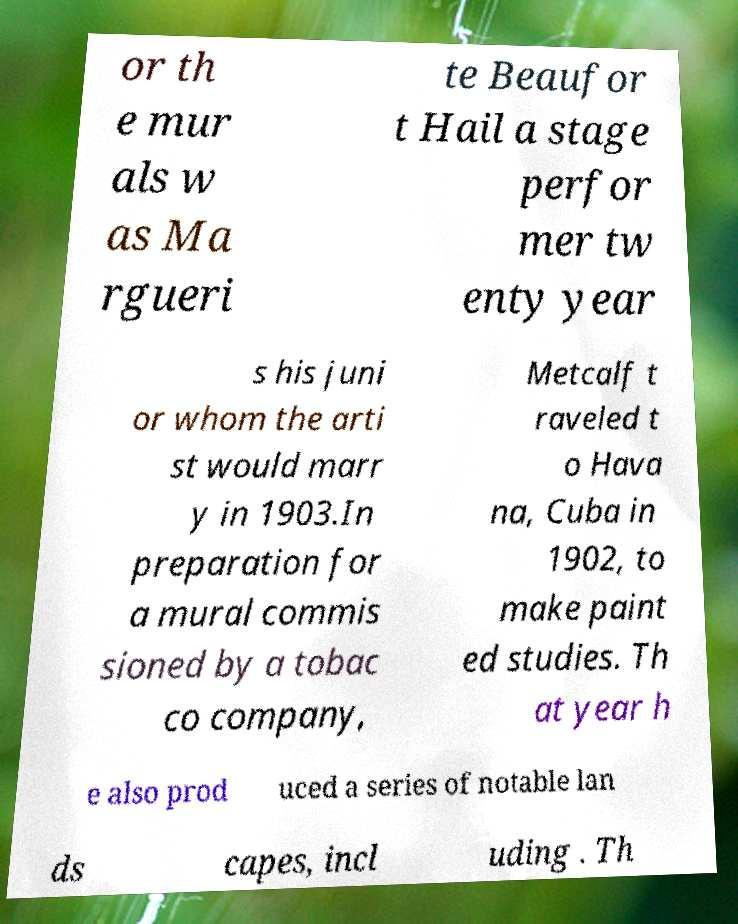What messages or text are displayed in this image? I need them in a readable, typed format. or th e mur als w as Ma rgueri te Beaufor t Hail a stage perfor mer tw enty year s his juni or whom the arti st would marr y in 1903.In preparation for a mural commis sioned by a tobac co company, Metcalf t raveled t o Hava na, Cuba in 1902, to make paint ed studies. Th at year h e also prod uced a series of notable lan ds capes, incl uding . Th 